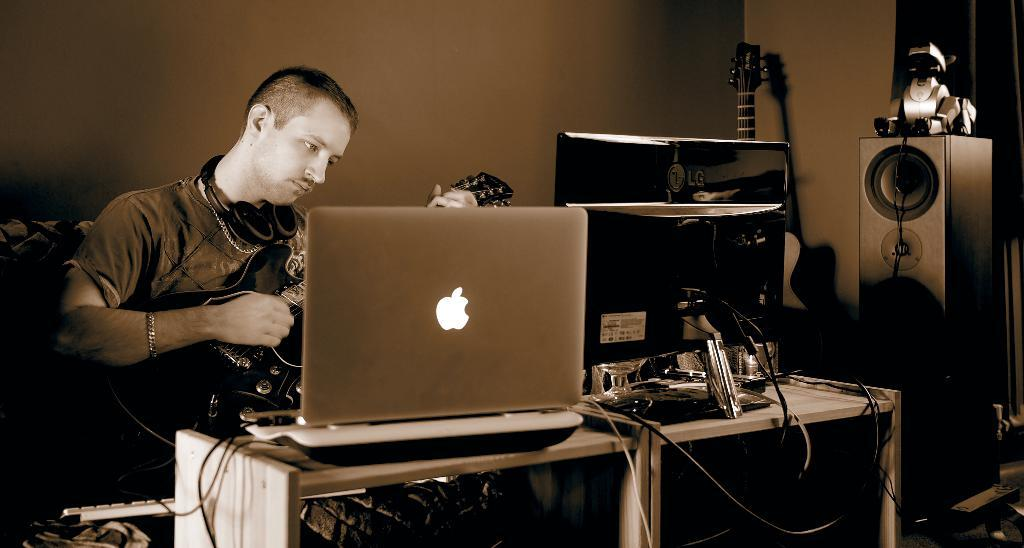What is the person in the image doing? The person is sitting in a sofa and playing a guitar. What is in front of the person? There is a table in front of the person. What can be seen on the table? The table has a desktop and a MacBook on it. Are there any other objects in the image? Yes, there is a speaker and a guitar in the right corner of the image. What type of flooring can be seen in the image? There is no information about the flooring in the image, as the focus is on the person and the objects around them. 